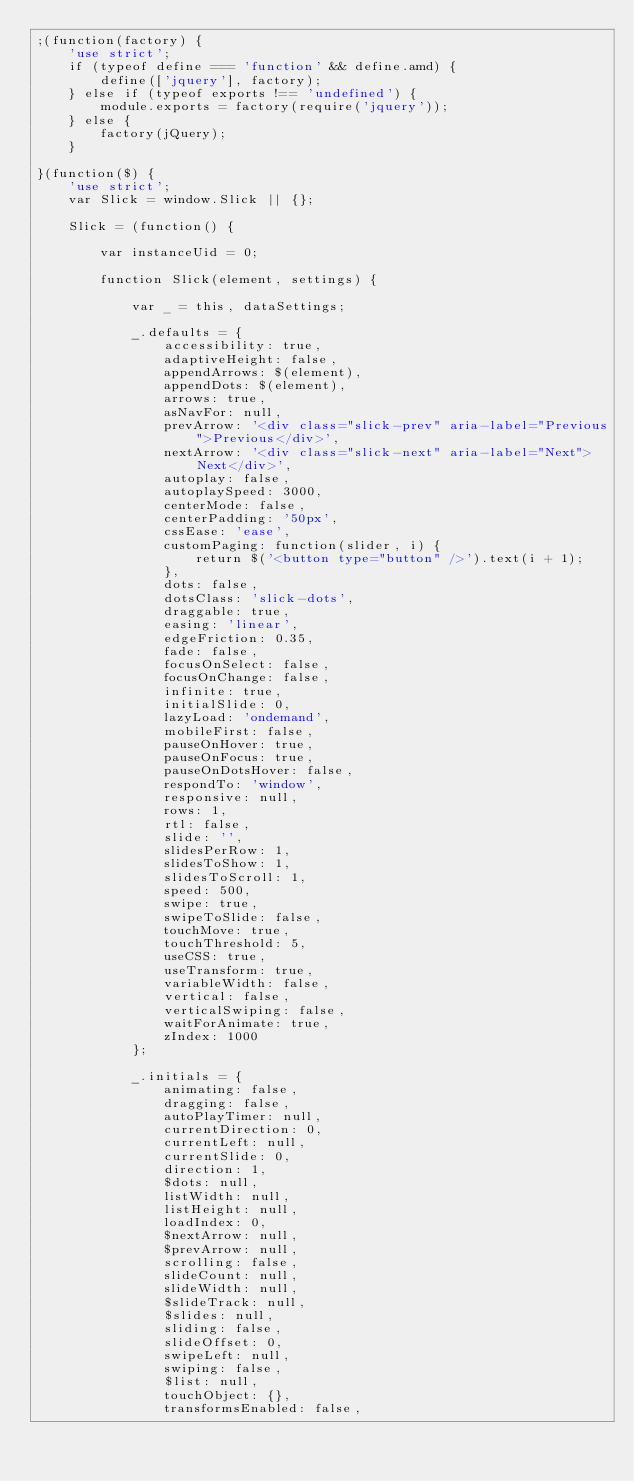<code> <loc_0><loc_0><loc_500><loc_500><_JavaScript_>;(function(factory) {
    'use strict';
    if (typeof define === 'function' && define.amd) {
        define(['jquery'], factory);
    } else if (typeof exports !== 'undefined') {
        module.exports = factory(require('jquery'));
    } else {
        factory(jQuery);
    }

}(function($) {
    'use strict';
    var Slick = window.Slick || {};

    Slick = (function() {

        var instanceUid = 0;

        function Slick(element, settings) {

            var _ = this, dataSettings;

            _.defaults = {
                accessibility: true,
                adaptiveHeight: false,
                appendArrows: $(element),
                appendDots: $(element),
                arrows: true,
                asNavFor: null,
                prevArrow: '<div class="slick-prev" aria-label="Previous">Previous</div>',
                nextArrow: '<div class="slick-next" aria-label="Next">Next</div>',
                autoplay: false,
                autoplaySpeed: 3000,
                centerMode: false,
                centerPadding: '50px',
                cssEase: 'ease',
                customPaging: function(slider, i) {
                    return $('<button type="button" />').text(i + 1);
                },
                dots: false,
                dotsClass: 'slick-dots',
                draggable: true,
                easing: 'linear',
                edgeFriction: 0.35,
                fade: false,
                focusOnSelect: false,
                focusOnChange: false,
                infinite: true,
                initialSlide: 0,
                lazyLoad: 'ondemand',
                mobileFirst: false,
                pauseOnHover: true,
                pauseOnFocus: true,
                pauseOnDotsHover: false,
                respondTo: 'window',
                responsive: null,
                rows: 1,
                rtl: false,
                slide: '',
                slidesPerRow: 1,
                slidesToShow: 1,
                slidesToScroll: 1,
                speed: 500,
                swipe: true,
                swipeToSlide: false,
                touchMove: true,
                touchThreshold: 5,
                useCSS: true,
                useTransform: true,
                variableWidth: false,
                vertical: false,
                verticalSwiping: false,
                waitForAnimate: true,
                zIndex: 1000
            };

            _.initials = {
                animating: false,
                dragging: false,
                autoPlayTimer: null,
                currentDirection: 0,
                currentLeft: null,
                currentSlide: 0,
                direction: 1,
                $dots: null,
                listWidth: null,
                listHeight: null,
                loadIndex: 0,
                $nextArrow: null,
                $prevArrow: null,
                scrolling: false,
                slideCount: null,
                slideWidth: null,
                $slideTrack: null,
                $slides: null,
                sliding: false,
                slideOffset: 0,
                swipeLeft: null,
                swiping: false,
                $list: null,
                touchObject: {},
                transformsEnabled: false,</code> 